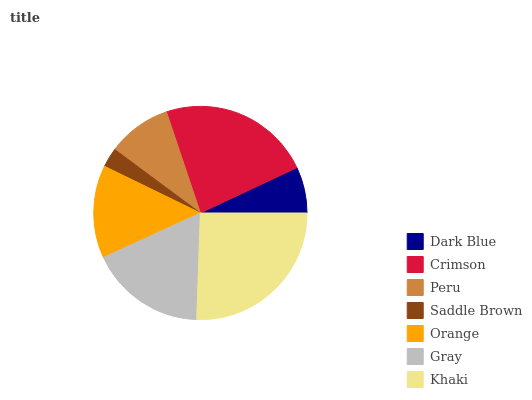Is Saddle Brown the minimum?
Answer yes or no. Yes. Is Khaki the maximum?
Answer yes or no. Yes. Is Crimson the minimum?
Answer yes or no. No. Is Crimson the maximum?
Answer yes or no. No. Is Crimson greater than Dark Blue?
Answer yes or no. Yes. Is Dark Blue less than Crimson?
Answer yes or no. Yes. Is Dark Blue greater than Crimson?
Answer yes or no. No. Is Crimson less than Dark Blue?
Answer yes or no. No. Is Orange the high median?
Answer yes or no. Yes. Is Orange the low median?
Answer yes or no. Yes. Is Crimson the high median?
Answer yes or no. No. Is Peru the low median?
Answer yes or no. No. 